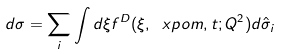<formula> <loc_0><loc_0><loc_500><loc_500>d \sigma = \sum _ { i } \int d \xi f ^ { D } ( \xi , \ x p o m , t ; Q ^ { 2 } ) d \hat { \sigma } _ { i }</formula> 